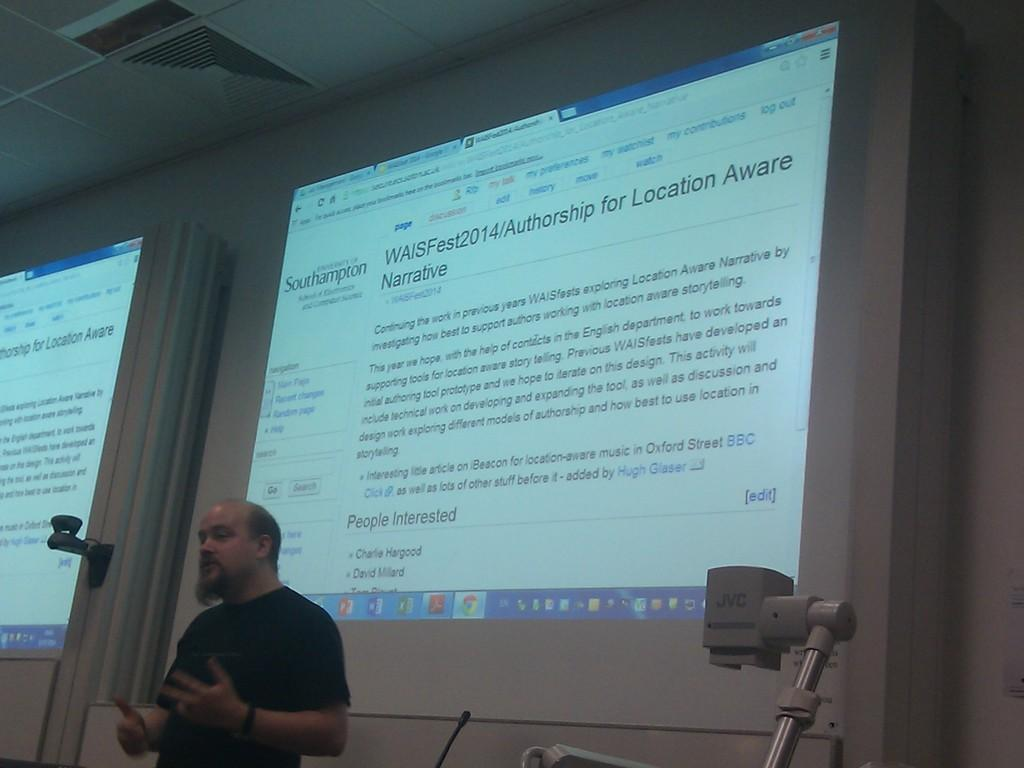What is the main subject of the image? There is a person standing in the image. What can be seen in the background of the image? There is a wall and a screen in the background of the image. What is displayed on the screen? There is text visible on the screen. What is visible at the top of the image? There is a ceiling visible at the top of the image. What type of crate is being used for educational purposes in the image? There is no crate present in the image, and no educational activities are depicted. 